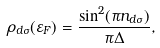<formula> <loc_0><loc_0><loc_500><loc_500>\rho _ { d \sigma } ( \varepsilon _ { F } ) = \frac { \sin ^ { 2 } ( \pi n _ { d \sigma } ) } { \pi \Delta } ,</formula> 